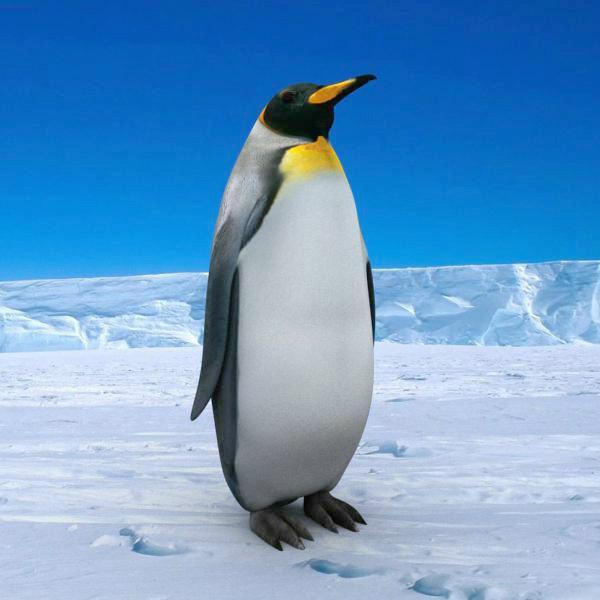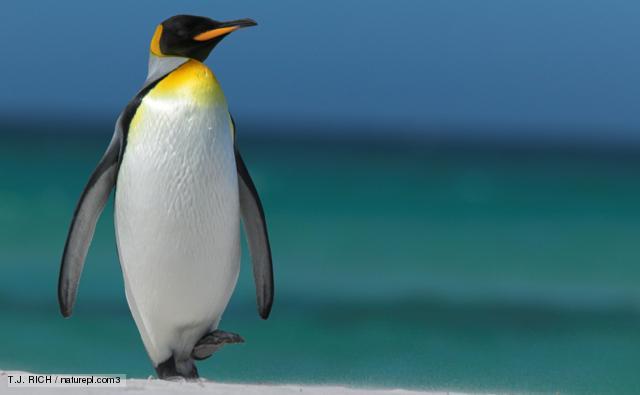The first image is the image on the left, the second image is the image on the right. For the images displayed, is the sentence "Each image contains one standing penguin, and all penguins have heads turned rightward." factually correct? Answer yes or no. Yes. The first image is the image on the left, the second image is the image on the right. Examine the images to the left and right. Is the description "There is only one penguin in each image and every penguin looks towards the right." accurate? Answer yes or no. Yes. 